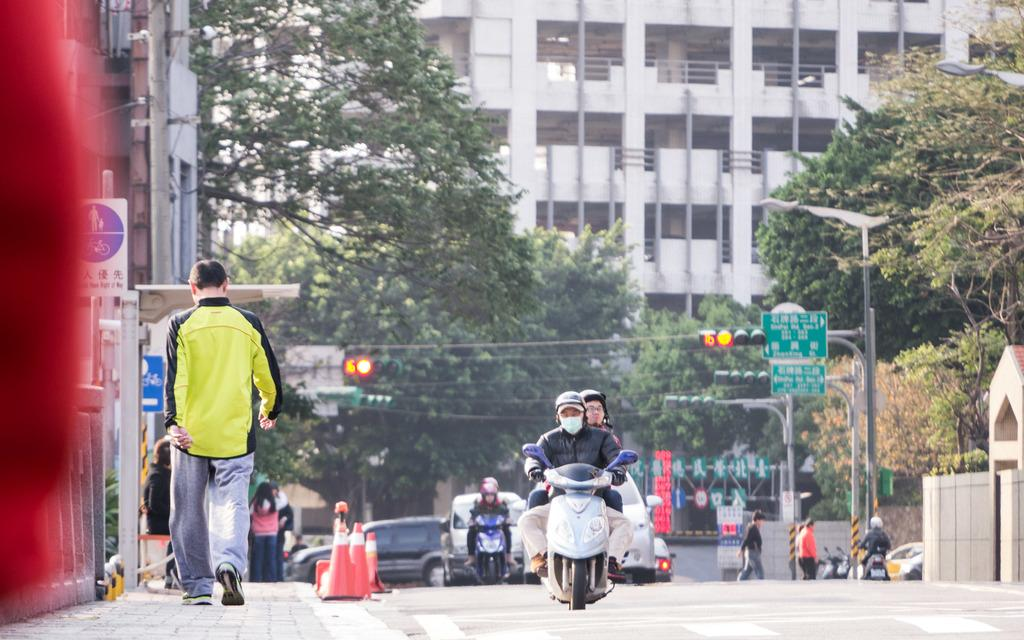How many people are in the image? There is a group of persons in the image. What are some of the people doing in the image? Some of the persons are walking, riding motorcycles, and driving cars. What can be seen in the background of the image? There are trees, buildings, and traffic signals in the background of the image. What type of meat is being served at the rest stop in the image? There is no rest stop or meat present in the image. Can you describe the woman in the image? There is no woman present in the image. 